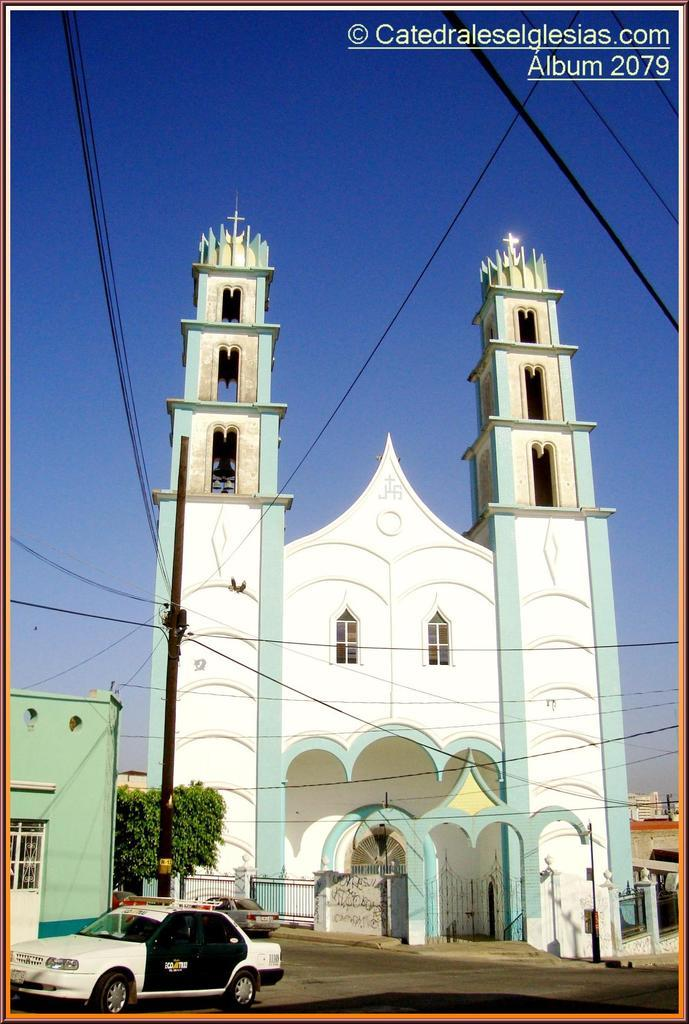Provide a one-sentence caption for the provided image. Album 2079 includes an image of a beautiful green and white church. 